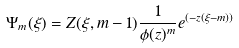<formula> <loc_0><loc_0><loc_500><loc_500>\Psi _ { m } ( \xi ) = Z ( \xi , m - 1 ) \frac { 1 } { \phi ( z ) ^ { m } } e ^ { ( - z ( \xi - m ) ) }</formula> 